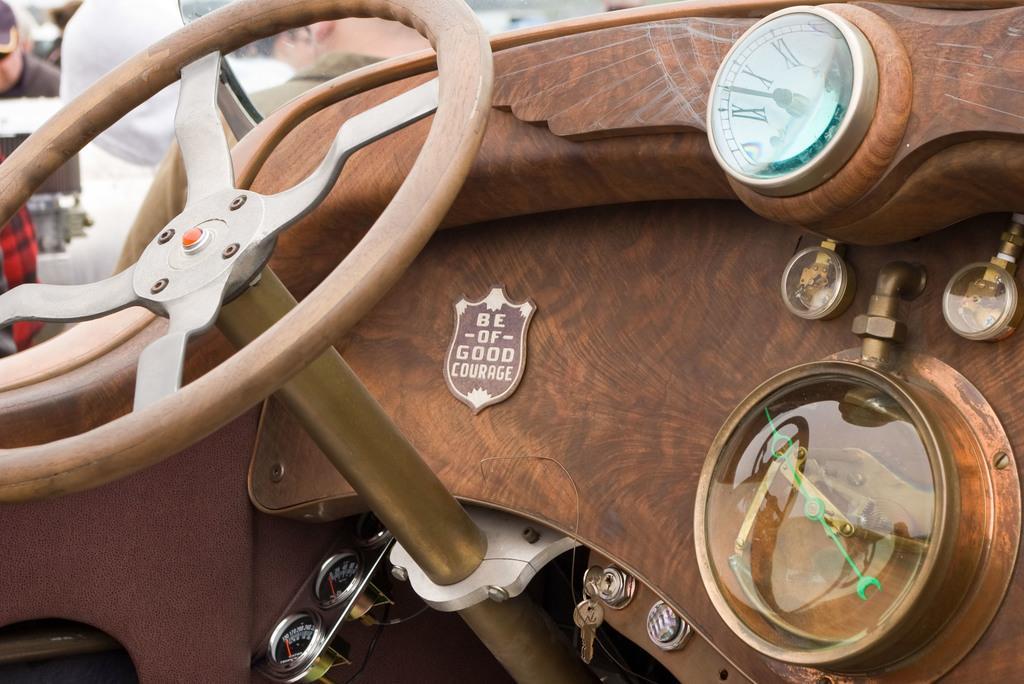Please provide a concise description of this image. In this image we can see a vehicle. In the background there are people. 